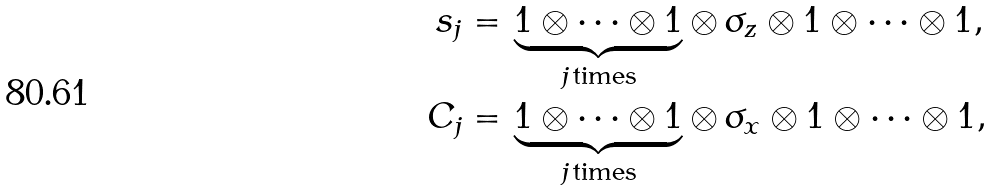Convert formula to latex. <formula><loc_0><loc_0><loc_500><loc_500>s _ { j } = & \, \underbrace { 1 \otimes \dots \otimes 1 } _ { j \, \text {times} } \otimes \, \sigma _ { z } \otimes 1 \otimes \dots \otimes 1 , \\ C _ { j } = & \, \underbrace { 1 \otimes \dots \otimes 1 } _ { j \, \text {times} } \otimes \, \sigma _ { x } \otimes 1 \otimes \dots \otimes 1 ,</formula> 